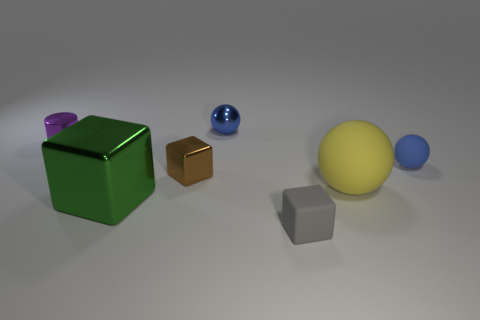What number of metallic cubes have the same size as the yellow object?
Offer a terse response. 1. What number of shiny things are behind the gray rubber object?
Your answer should be compact. 4. The tiny cube on the left side of the small blue ball that is behind the tiny blue matte object is made of what material?
Keep it short and to the point. Metal. Are there any other spheres that have the same color as the small matte ball?
Your response must be concise. Yes. There is another cube that is made of the same material as the brown block; what size is it?
Your answer should be very brief. Large. Is there anything else that is the same color as the small rubber block?
Offer a very short reply. No. What color is the small metallic object behind the purple shiny cylinder?
Keep it short and to the point. Blue. There is a tiny blue sphere left of the tiny ball that is right of the yellow object; are there any small blue metal spheres to the right of it?
Give a very brief answer. No. Is the number of green blocks that are behind the green metallic thing greater than the number of yellow objects?
Your answer should be compact. No. Does the tiny metallic thing in front of the blue matte sphere have the same shape as the small blue metallic object?
Provide a succinct answer. No. 